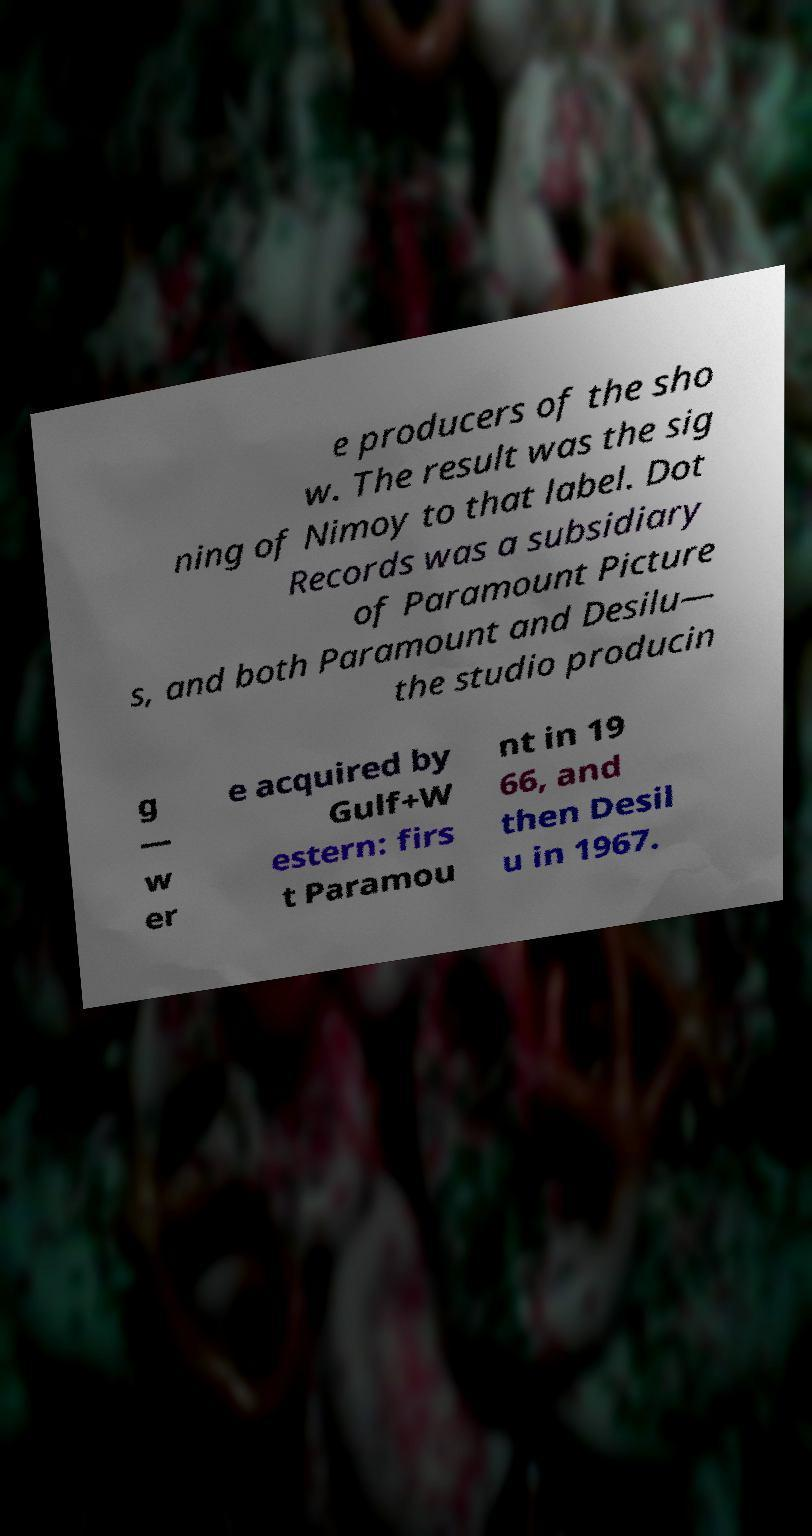For documentation purposes, I need the text within this image transcribed. Could you provide that? e producers of the sho w. The result was the sig ning of Nimoy to that label. Dot Records was a subsidiary of Paramount Picture s, and both Paramount and Desilu— the studio producin g — w er e acquired by Gulf+W estern: firs t Paramou nt in 19 66, and then Desil u in 1967. 